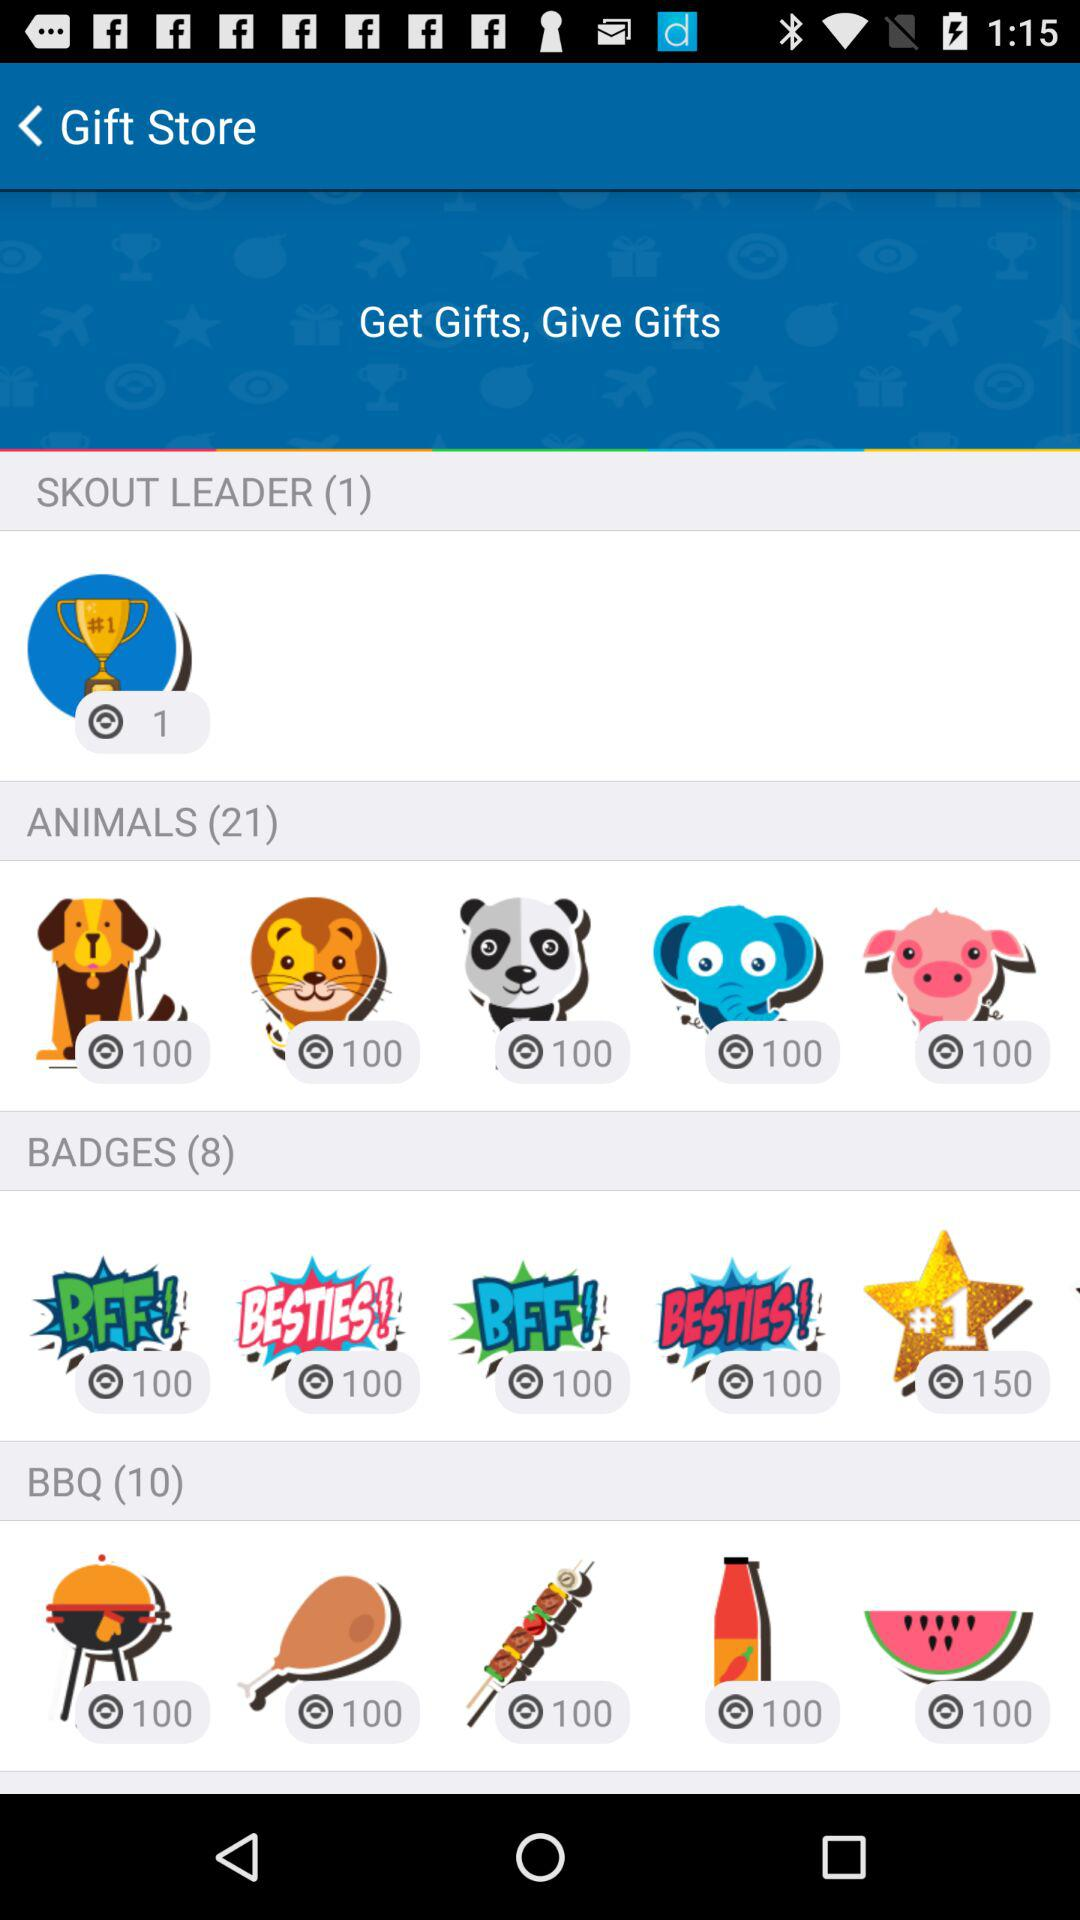What is the count of badges? The count of badges is 8. 